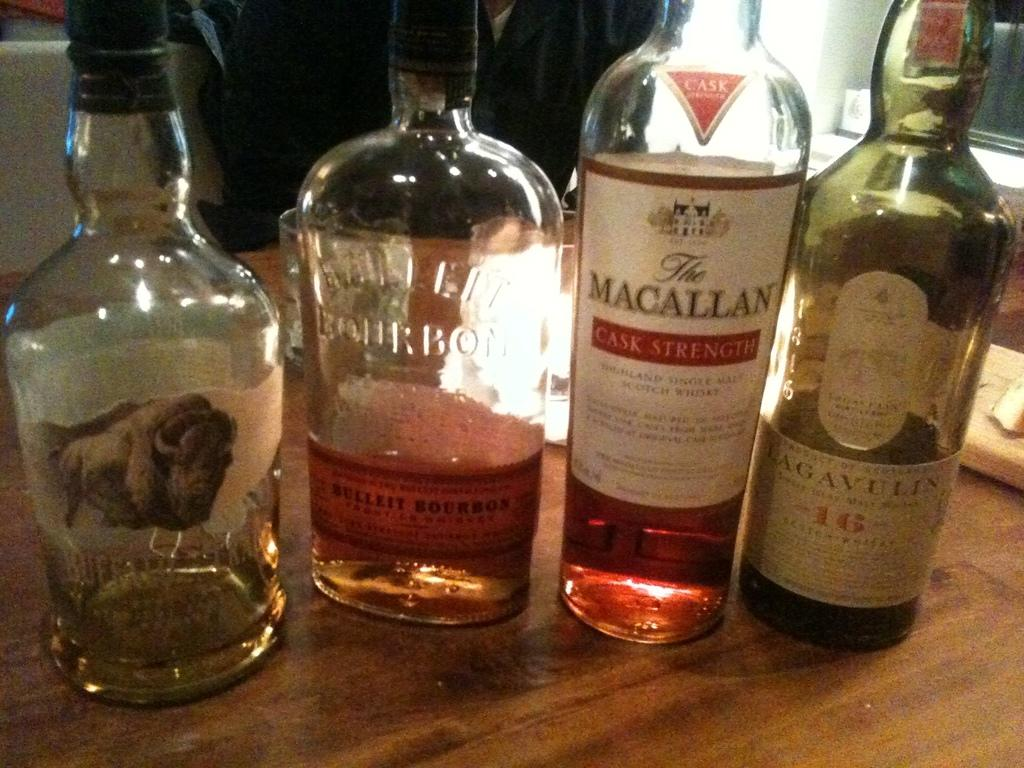<image>
Summarize the visual content of the image. Four different kinds of whiskey are on a table, two Scotches and two Bourbons. 